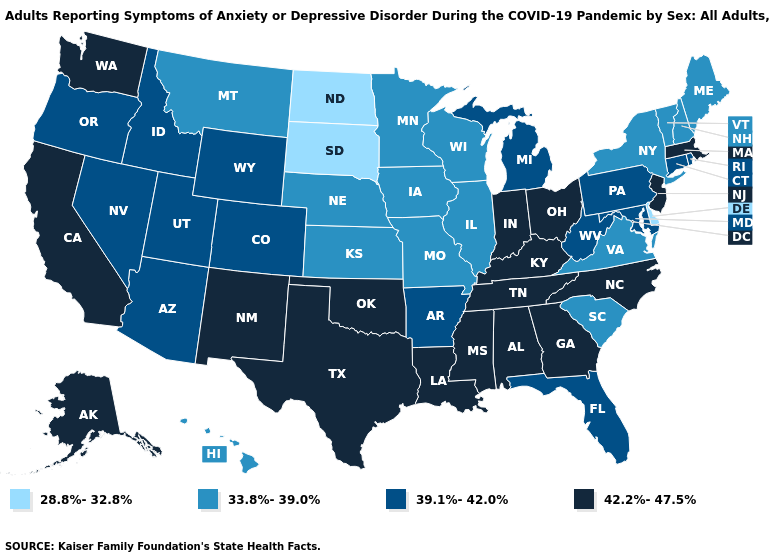Among the states that border Tennessee , does Virginia have the highest value?
Be succinct. No. Which states have the lowest value in the South?
Answer briefly. Delaware. Is the legend a continuous bar?
Give a very brief answer. No. How many symbols are there in the legend?
Keep it brief. 4. Which states have the highest value in the USA?
Give a very brief answer. Alabama, Alaska, California, Georgia, Indiana, Kentucky, Louisiana, Massachusetts, Mississippi, New Jersey, New Mexico, North Carolina, Ohio, Oklahoma, Tennessee, Texas, Washington. Name the states that have a value in the range 39.1%-42.0%?
Quick response, please. Arizona, Arkansas, Colorado, Connecticut, Florida, Idaho, Maryland, Michigan, Nevada, Oregon, Pennsylvania, Rhode Island, Utah, West Virginia, Wyoming. What is the value of New Mexico?
Concise answer only. 42.2%-47.5%. Name the states that have a value in the range 28.8%-32.8%?
Write a very short answer. Delaware, North Dakota, South Dakota. Does the first symbol in the legend represent the smallest category?
Write a very short answer. Yes. Name the states that have a value in the range 39.1%-42.0%?
Concise answer only. Arizona, Arkansas, Colorado, Connecticut, Florida, Idaho, Maryland, Michigan, Nevada, Oregon, Pennsylvania, Rhode Island, Utah, West Virginia, Wyoming. What is the value of Kansas?
Give a very brief answer. 33.8%-39.0%. What is the value of Rhode Island?
Keep it brief. 39.1%-42.0%. What is the value of Minnesota?
Concise answer only. 33.8%-39.0%. What is the value of Louisiana?
Answer briefly. 42.2%-47.5%. 